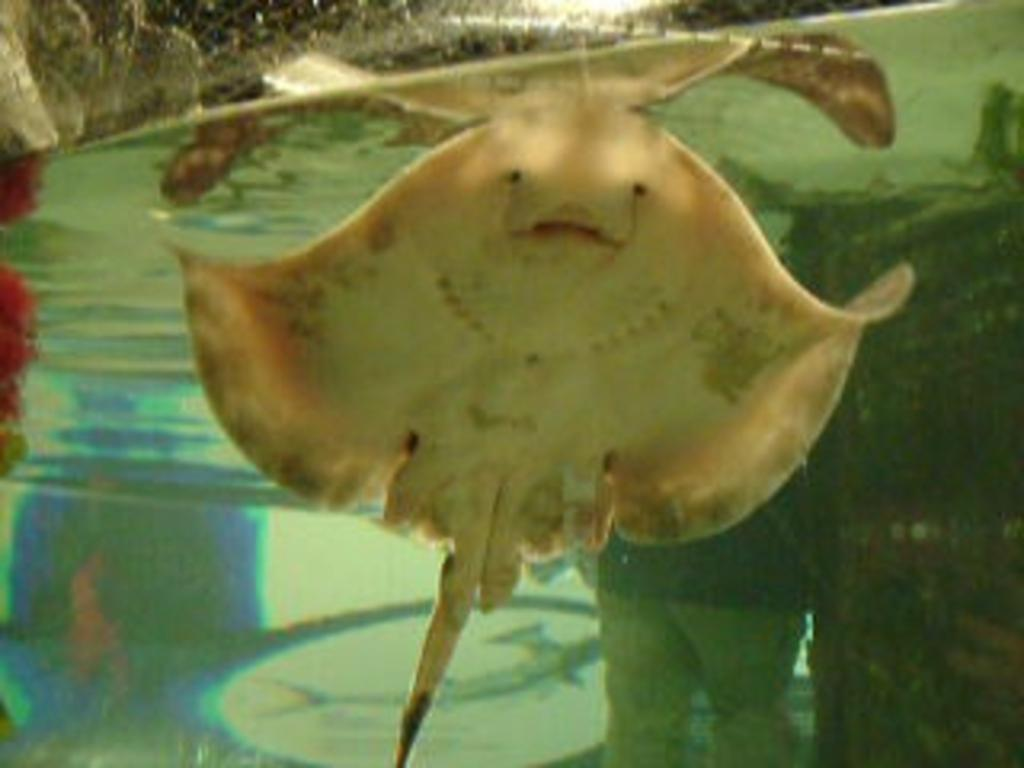What type of animal can be seen in the water in the image? There is a stingray fish in the water in the image. What part of a person is visible in the image? Human legs are visible in the image. What type of skin can be seen on the stingray's mouth in the image? There is no stingray's mouth visible in the image, as only the fish's body is shown. 